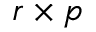<formula> <loc_0><loc_0><loc_500><loc_500>r \times p</formula> 